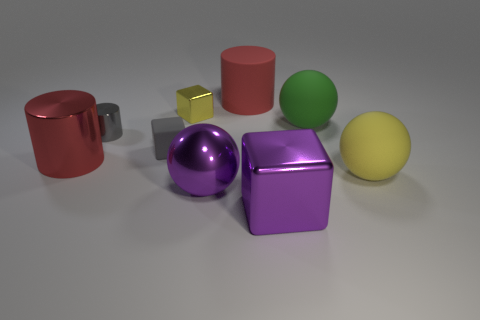Subtract all red blocks. How many red cylinders are left? 2 Subtract all big red cylinders. How many cylinders are left? 1 Add 1 big cubes. How many objects exist? 10 Subtract all cubes. How many objects are left? 6 Subtract all gray things. Subtract all big red metal objects. How many objects are left? 6 Add 7 tiny gray rubber blocks. How many tiny gray rubber blocks are left? 8 Add 5 big purple objects. How many big purple objects exist? 7 Subtract 0 brown cylinders. How many objects are left? 9 